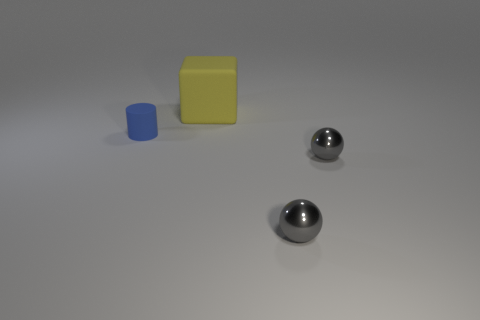Does the thing that is left of the large yellow matte thing have the same color as the rubber cube?
Make the answer very short. No. Are there an equal number of rubber cubes that are in front of the small blue object and small blue things that are on the left side of the yellow object?
Keep it short and to the point. No. Is there anything else that has the same material as the tiny cylinder?
Make the answer very short. Yes. There is a object left of the large yellow rubber thing; what color is it?
Keep it short and to the point. Blue. Are there the same number of small gray shiny things in front of the big yellow thing and small metal objects?
Make the answer very short. Yes. What number of other things are there of the same shape as the big object?
Make the answer very short. 0. There is a blue cylinder; what number of large yellow matte cubes are on the left side of it?
Your answer should be very brief. 0. Are any big yellow metallic cylinders visible?
Keep it short and to the point. No. How many other things are there of the same size as the blue cylinder?
Offer a very short reply. 2. Do the matte thing behind the small cylinder and the small object left of the yellow matte cube have the same color?
Your answer should be very brief. No. 